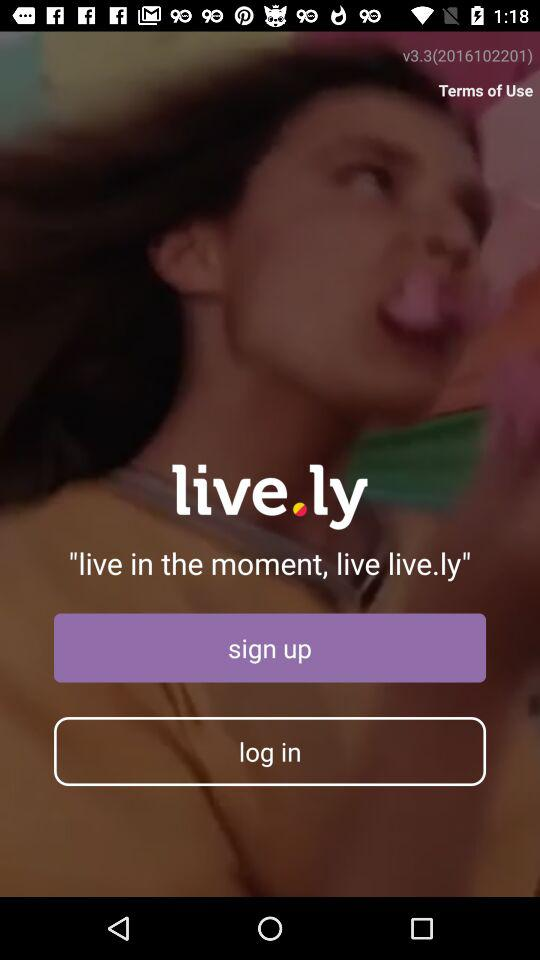What is the version number? The version number is v3.3 (2016102201). 